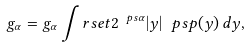Convert formula to latex. <formula><loc_0><loc_0><loc_500><loc_500>g _ { \alpha } = g _ { \alpha } \int _ { \ } r s e t 2 ^ { \ p s \alpha } | y | ^ { \ } p s p ( y ) \, d y ,</formula> 